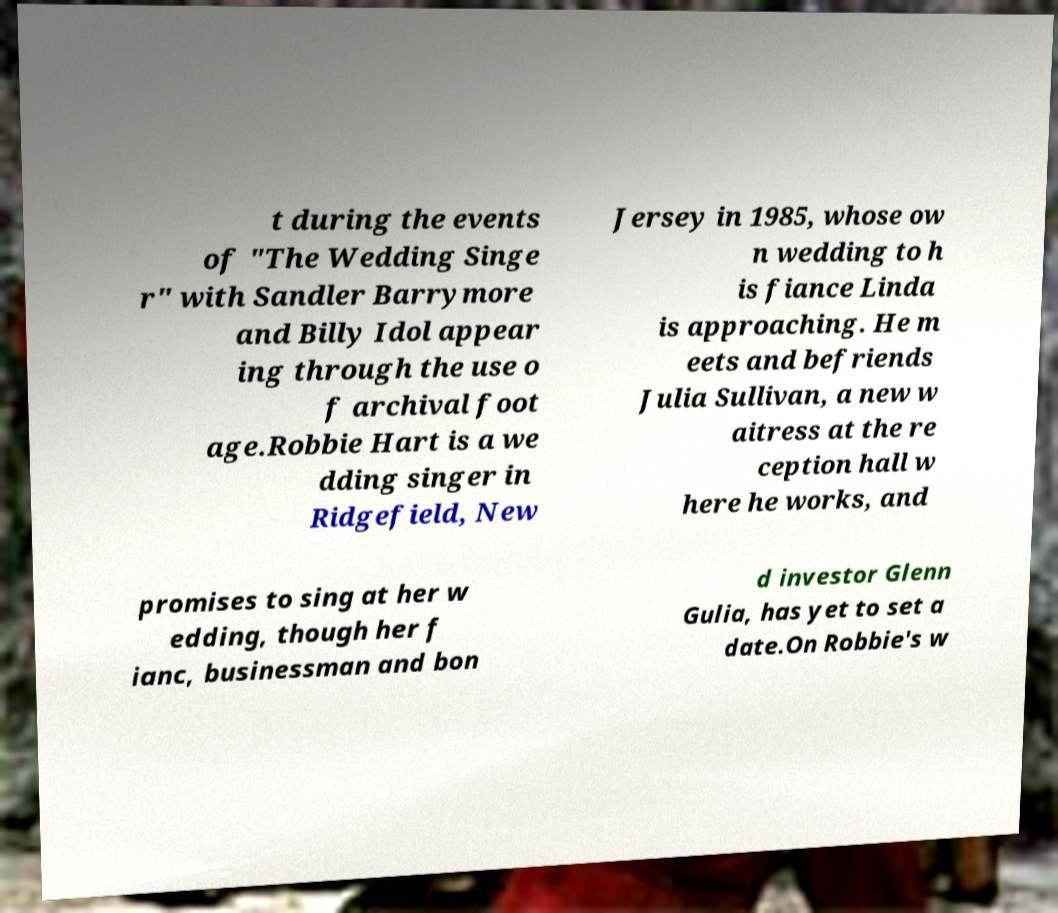Could you extract and type out the text from this image? t during the events of "The Wedding Singe r" with Sandler Barrymore and Billy Idol appear ing through the use o f archival foot age.Robbie Hart is a we dding singer in Ridgefield, New Jersey in 1985, whose ow n wedding to h is fiance Linda is approaching. He m eets and befriends Julia Sullivan, a new w aitress at the re ception hall w here he works, and promises to sing at her w edding, though her f ianc, businessman and bon d investor Glenn Gulia, has yet to set a date.On Robbie's w 